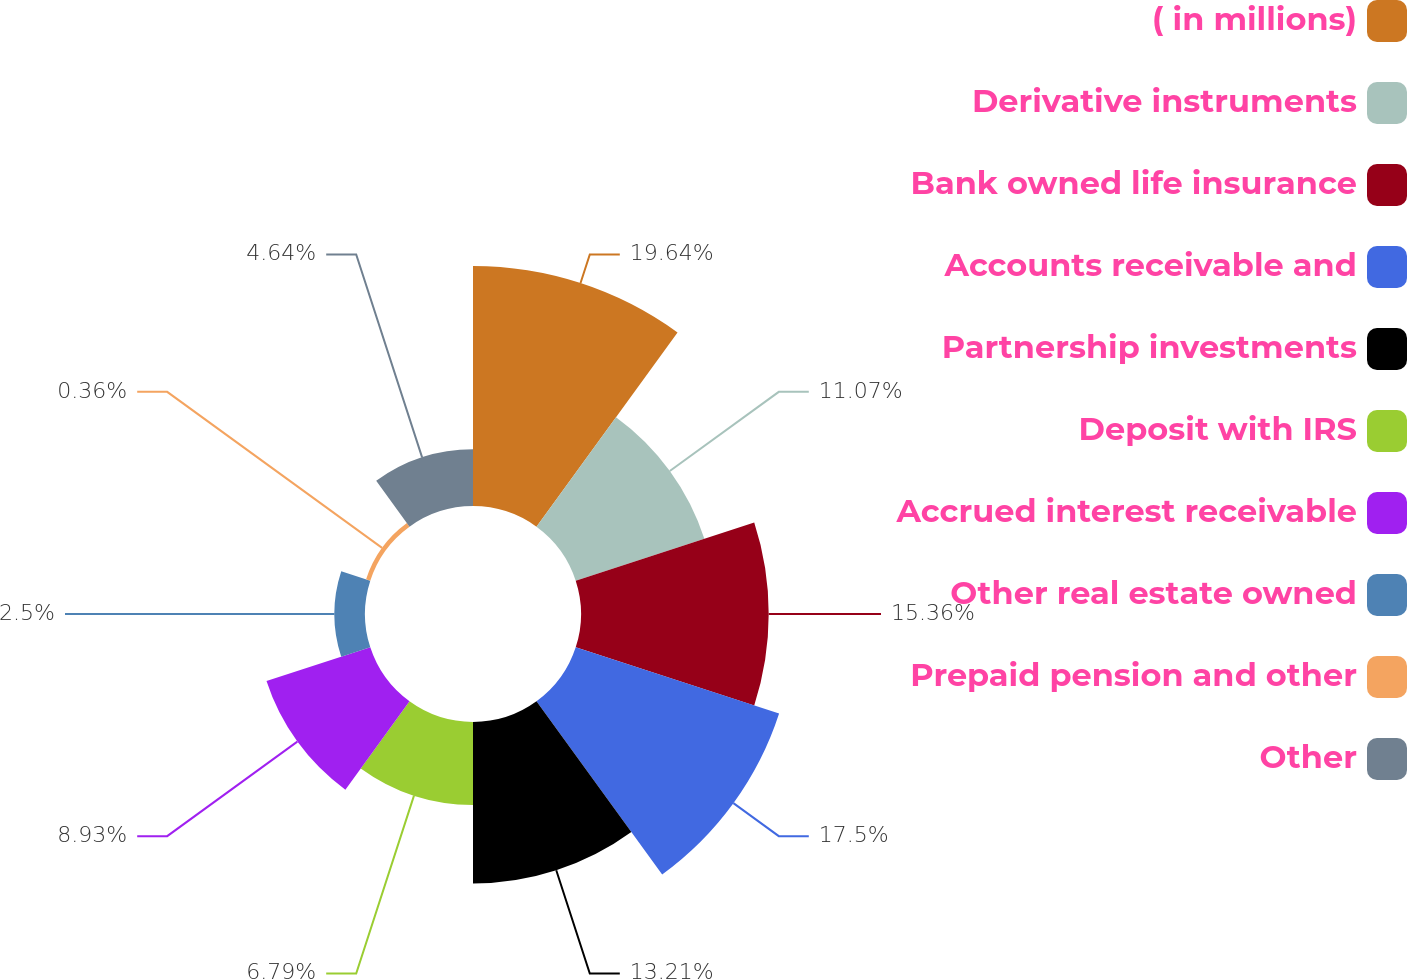<chart> <loc_0><loc_0><loc_500><loc_500><pie_chart><fcel>( in millions)<fcel>Derivative instruments<fcel>Bank owned life insurance<fcel>Accounts receivable and<fcel>Partnership investments<fcel>Deposit with IRS<fcel>Accrued interest receivable<fcel>Other real estate owned<fcel>Prepaid pension and other<fcel>Other<nl><fcel>19.64%<fcel>11.07%<fcel>15.36%<fcel>17.5%<fcel>13.21%<fcel>6.79%<fcel>8.93%<fcel>2.5%<fcel>0.36%<fcel>4.64%<nl></chart> 